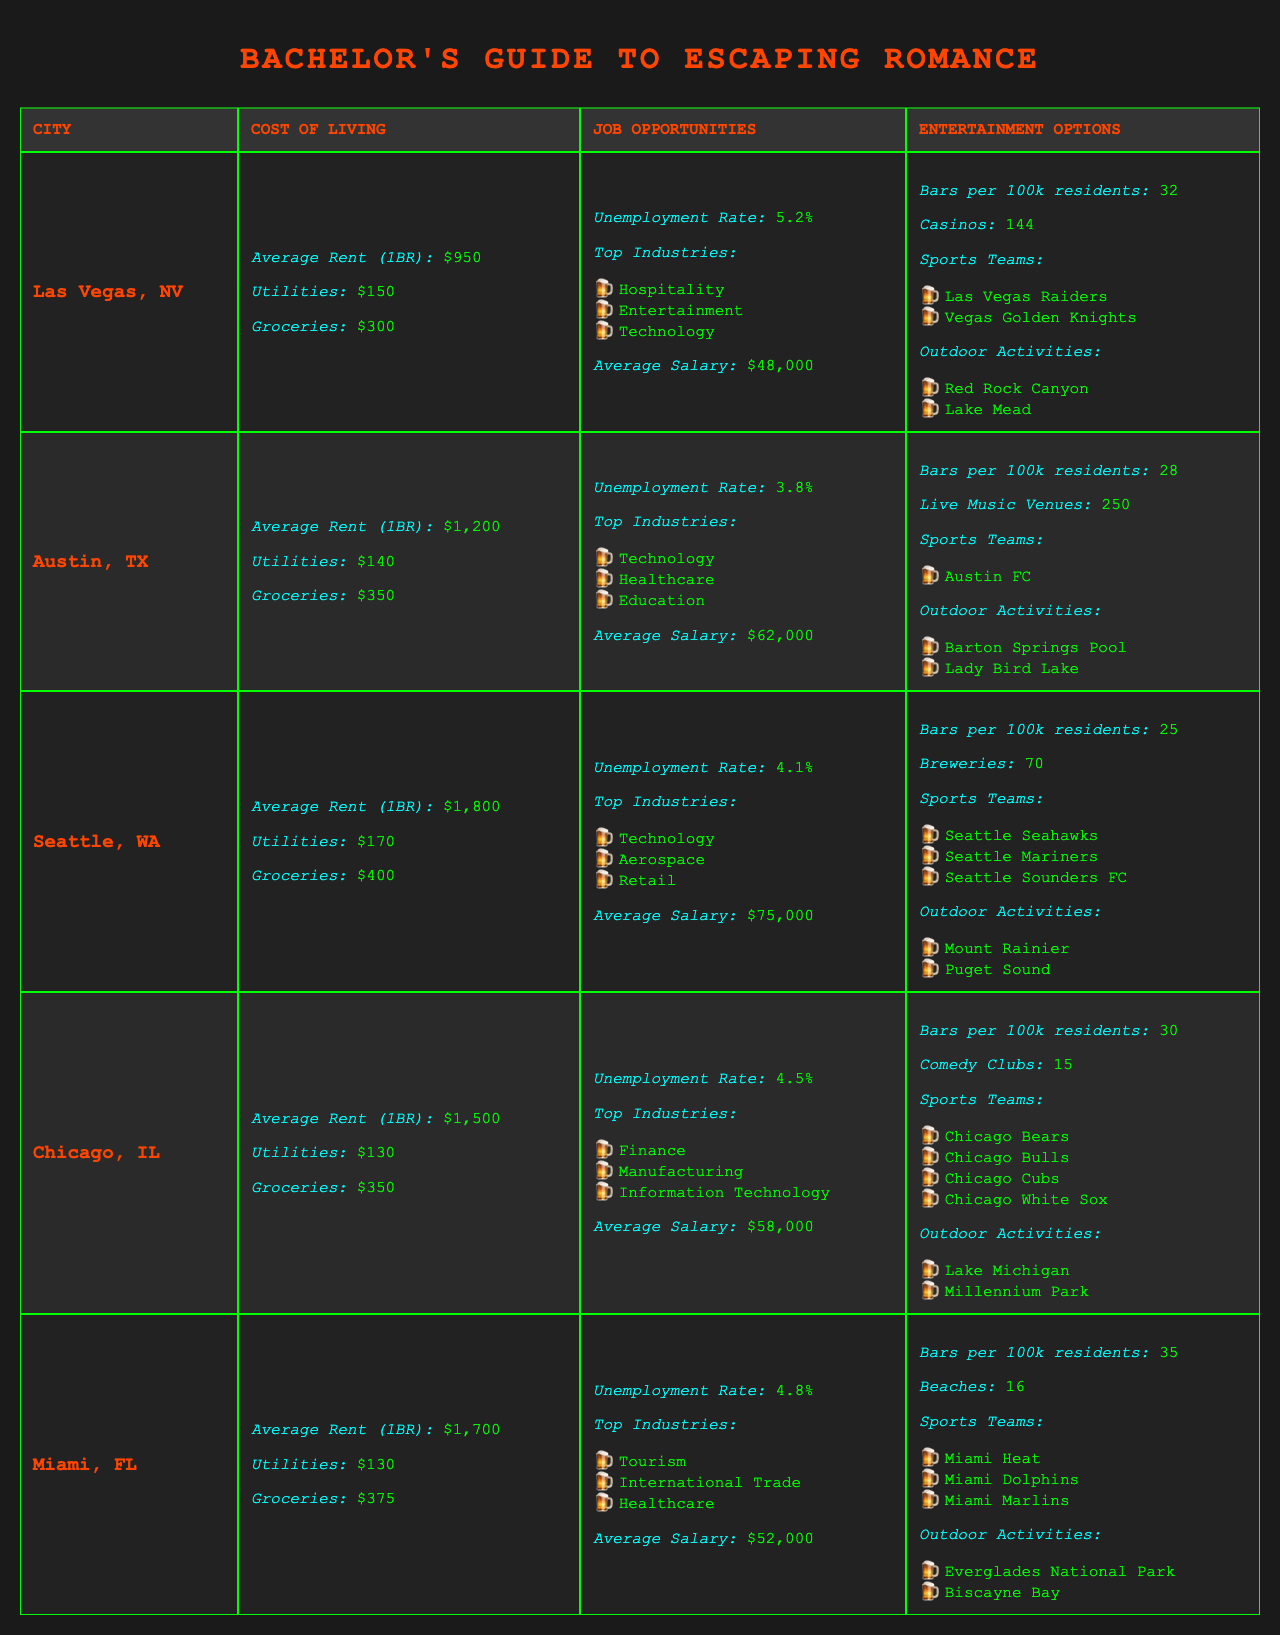What city has the highest average rent for a 1-bedroom apartment? By examining the cost of living section of the table, Seattle shows an average rent of $1,800, which is higher than the other cities listed.
Answer: Seattle, WA Which city has the lowest unemployment rate? The unemployment rate is listed under job opportunities for each city. Austin has the lowest unemployment rate at 3.8%, compared to the others.
Answer: Austin, TX What is the average rent for a 1-bedroom apartment in Miami? The cost of living section specifically lists the average rent for Miami as $1,700.
Answer: $1,700 How many sports teams does Chicago have? Reviewing the entertainment options for Chicago, it lists four sports teams: Chicago Bears, Chicago Bulls, Chicago Cubs, and Chicago White Sox.
Answer: 4 Which city offers the most outdoor activities? By comparing the outdoor activities listed for each city, Austin and Miami both have two activities, but Las Vegas has two as well. Only Seattle and Chicago have two distinct activities each. Thus, there isn't a definitive winner based on this criterion.
Answer: Tie between Austin, Miami, Las Vegas, Seattle, and Chicago What is the total cost of living (average rent + utilities + groceries) in Las Vegas? For Las Vegas, the average rent is $950, utilities are $150, and groceries are $300. Adding these values gives: 950 + 150 + 300 = 1,400.
Answer: $1,400 Which city has more bars per 100k residents: Las Vegas or Miami? The table indicates that Las Vegas has 32 bars per 100k residents while Miami has 35. This shows that Miami has more bars per capita.
Answer: Miami Is the average salary in Seattle higher than in Austin? The average salary in Seattle is $75,000, while in Austin, it is $62,000. Therefore, Seattle's average salary is indeed higher.
Answer: Yes How does the average cost of groceries in Chicago compare to Miami? In Chicago, the average cost of groceries is $350, while in Miami, it is $375. Thus, groceries are more expensive in Miami compared to Chicago.
Answer: Miami is more expensive Which city has the most top industries listed? By reviewing the top industries for each city, both Austin and Seattle have three listed, while the others have fewer. This means Austin and Seattle are tied for the most identified top industries.
Answer: Tie between Austin and Seattle 